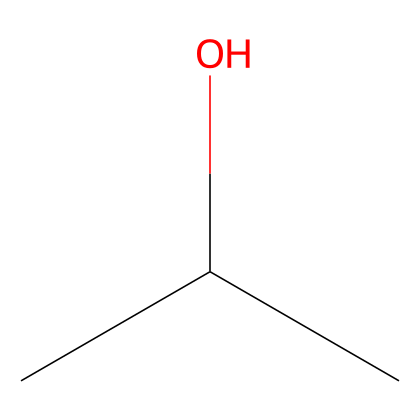How many carbon atoms are present in isopropyl alcohol? By examining the SMILES representation, "CC(C)O", we can identify there are three carbon atoms, as indicated by the three "C" symbols.
Answer: 3 What is the functional group present in isopropyl alcohol? The 'O' in the SMILES, when attached to carbon, signifies that this compound contains a hydroxyl functional group (-OH), which characterizes alcohols.
Answer: hydroxyl How many hydrogen atoms are in isopropyl alcohol? The SMILES indicates three carbon atoms and the connectivity shows each carbon is typically bonded to enough hydrogen atoms to satisfy carbon's tetravalency. Thus, calculating the hydrogen yields seven total hydrogen atoms.
Answer: 8 Why is isopropyl alcohol effective for cleaning? The structure of isopropyl alcohol with its hydroxyl group allows it to interact with both polar and nonpolar substances, making it an effective solvent for cleaning various contaminants.
Answer: effective solvent What type of compound is isopropyl alcohol classified as? Given its carbon and hydroxyl structure, isopropyl alcohol fits the definition of an aliphatic alcohol, specifically a secondary alcohol because the carbon bearing the hydroxyl group is attached to two other carbons.
Answer: aliphatic alcohol Is isopropyl alcohol saturated or unsaturated? The presence of only single bonds between carbon atoms, as depicted in the SMILES, indicates that isopropyl alcohol is a saturated compound where no double or triple bonds exist.
Answer: saturated What type of bond connects the carbon atoms in isopropyl alcohol? The structure shown in the SMILES contains only single bonds between the carbon atoms, meaning that each bond connecting them is a sigma bond, which is characteristic of aliphatic compounds.
Answer: sigma bonds 